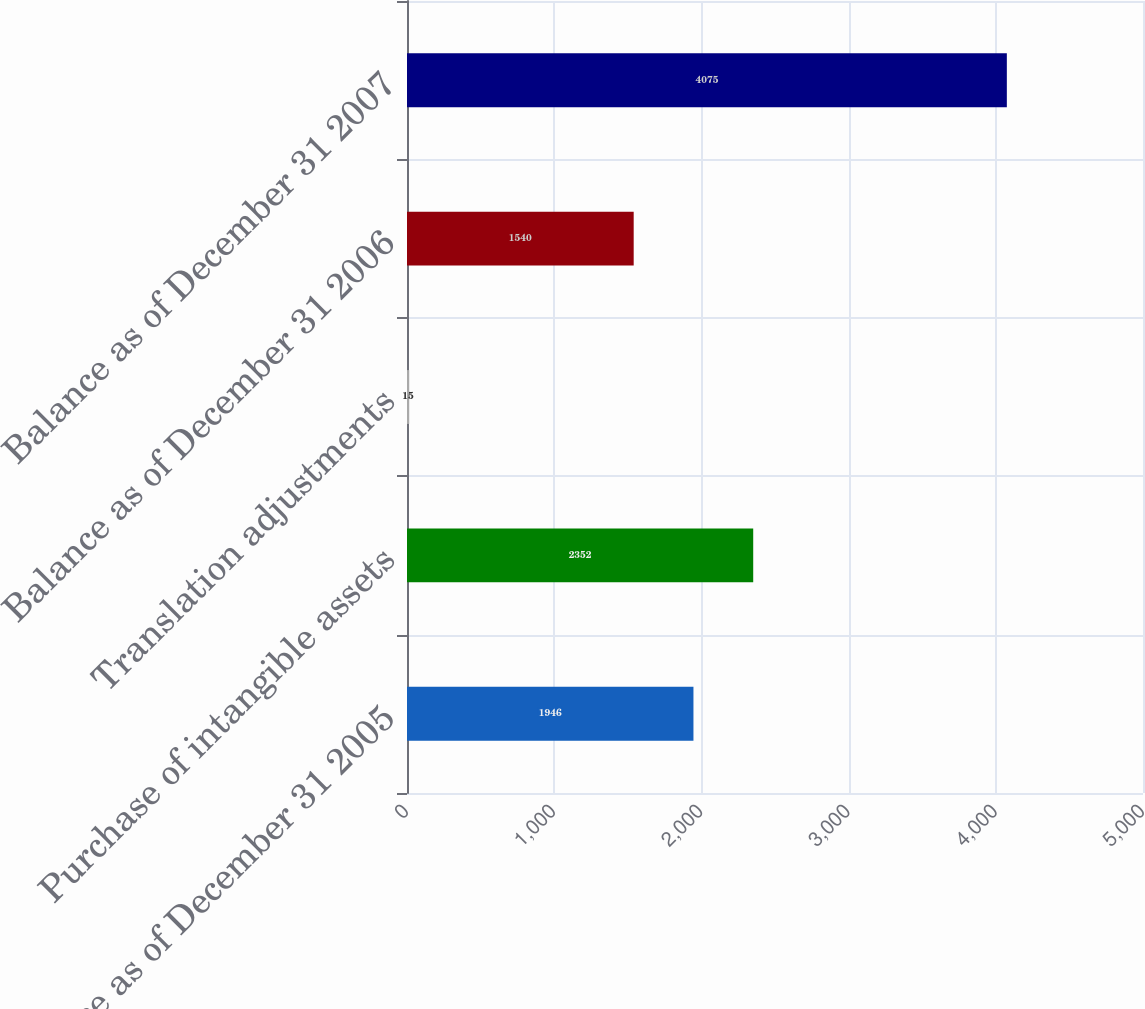Convert chart. <chart><loc_0><loc_0><loc_500><loc_500><bar_chart><fcel>Balance as of December 31 2005<fcel>Purchase of intangible assets<fcel>Translation adjustments<fcel>Balance as of December 31 2006<fcel>Balance as of December 31 2007<nl><fcel>1946<fcel>2352<fcel>15<fcel>1540<fcel>4075<nl></chart> 